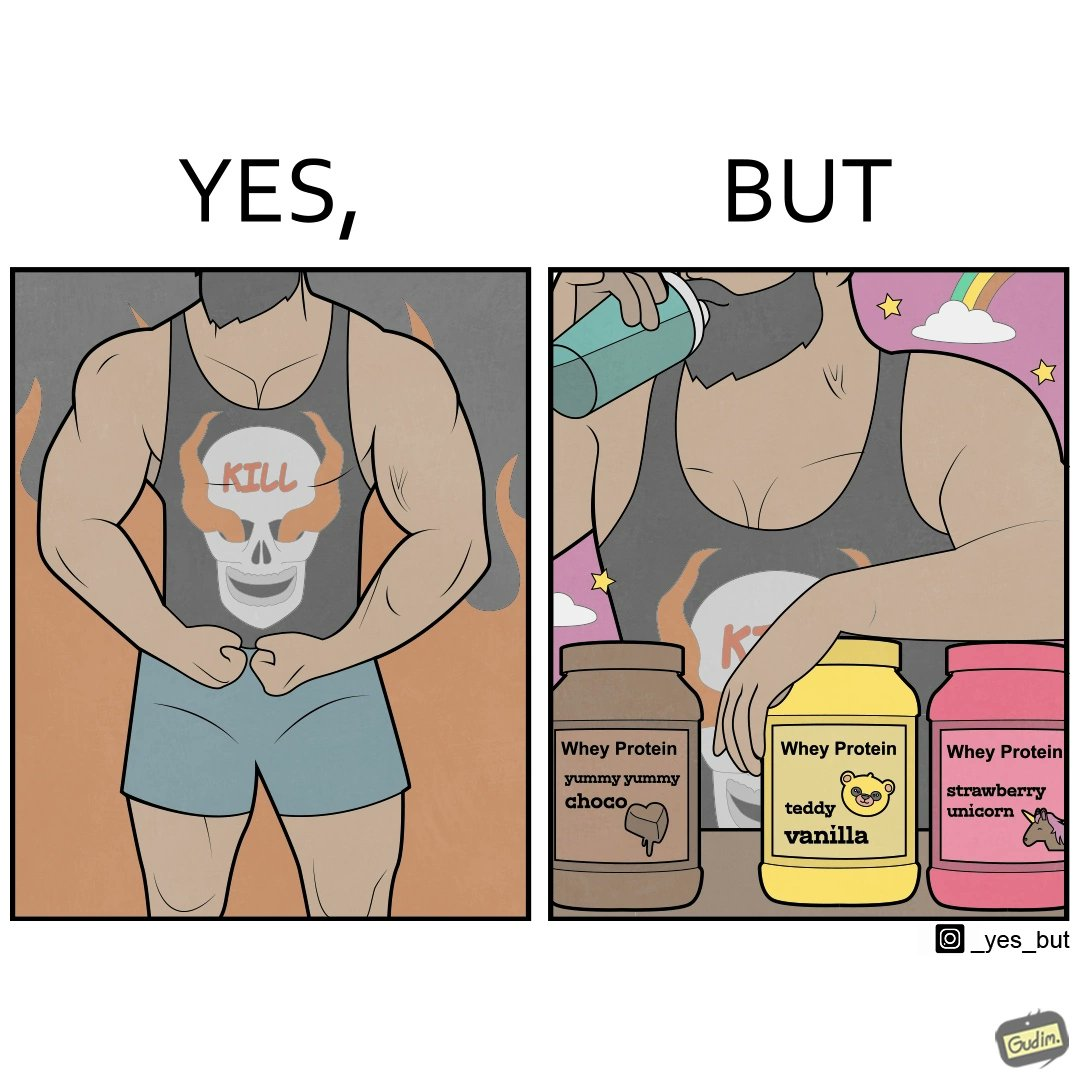Is this a satirical image? Yes, this image is satirical. 